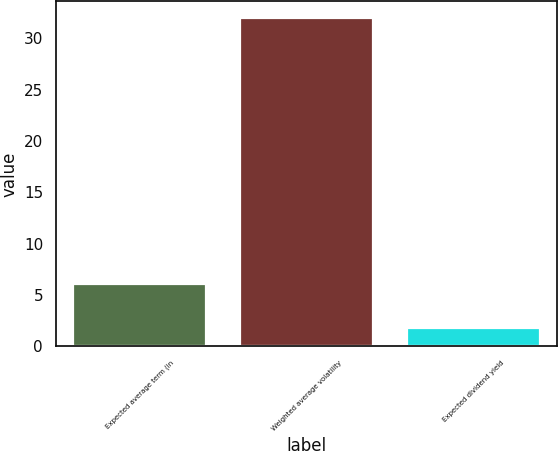Convert chart to OTSL. <chart><loc_0><loc_0><loc_500><loc_500><bar_chart><fcel>Expected average term (in<fcel>Weighted average volatility<fcel>Expected dividend yield<nl><fcel>6.1<fcel>32<fcel>1.8<nl></chart> 